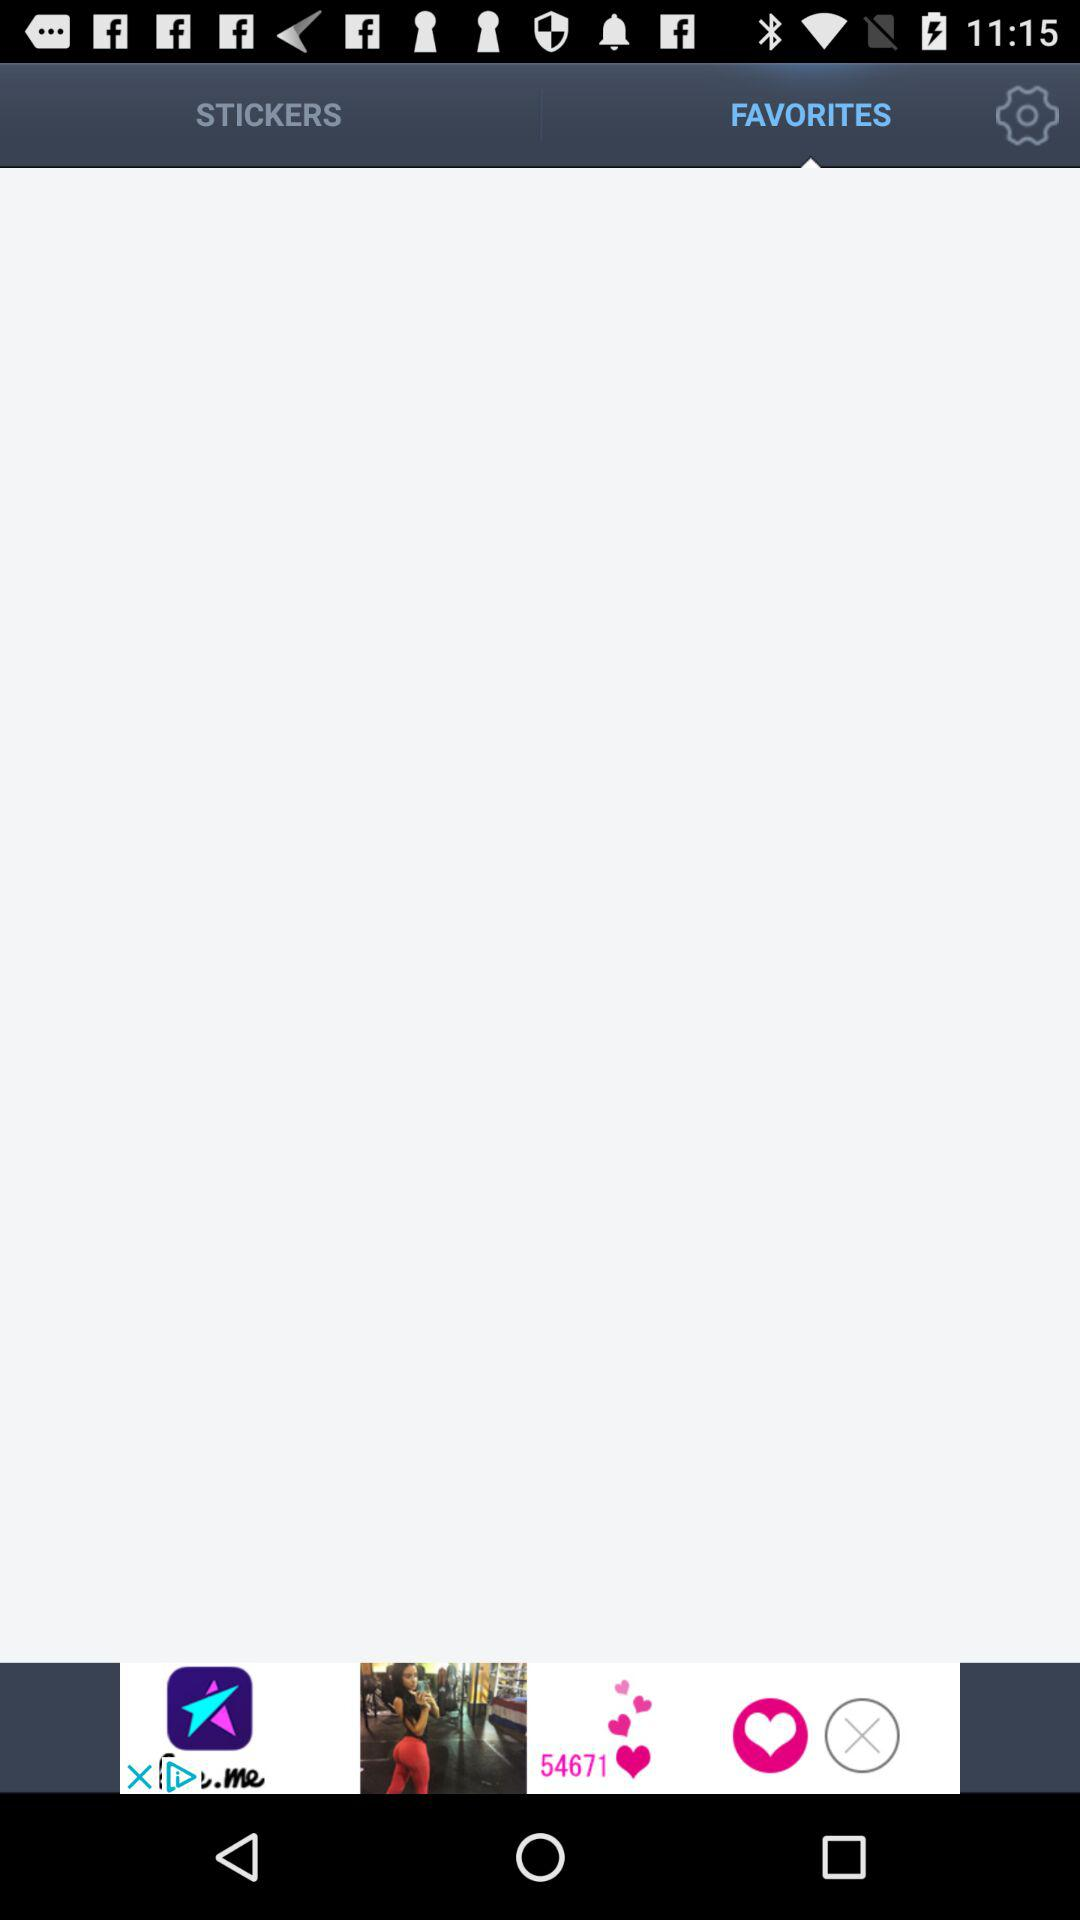What is the selected tab? The selected tab is "FAVORITES". 